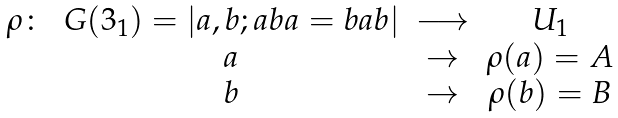Convert formula to latex. <formula><loc_0><loc_0><loc_500><loc_500>\begin{array} { c c c c } \rho \colon & G ( 3 _ { 1 } ) = | a , b ; a b a = b a b | & \longrightarrow & U _ { 1 } \\ & a & \rightarrow & \rho ( a ) = A \\ & b & \rightarrow & \rho ( b ) = B \end{array}</formula> 